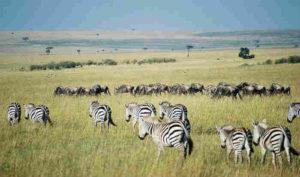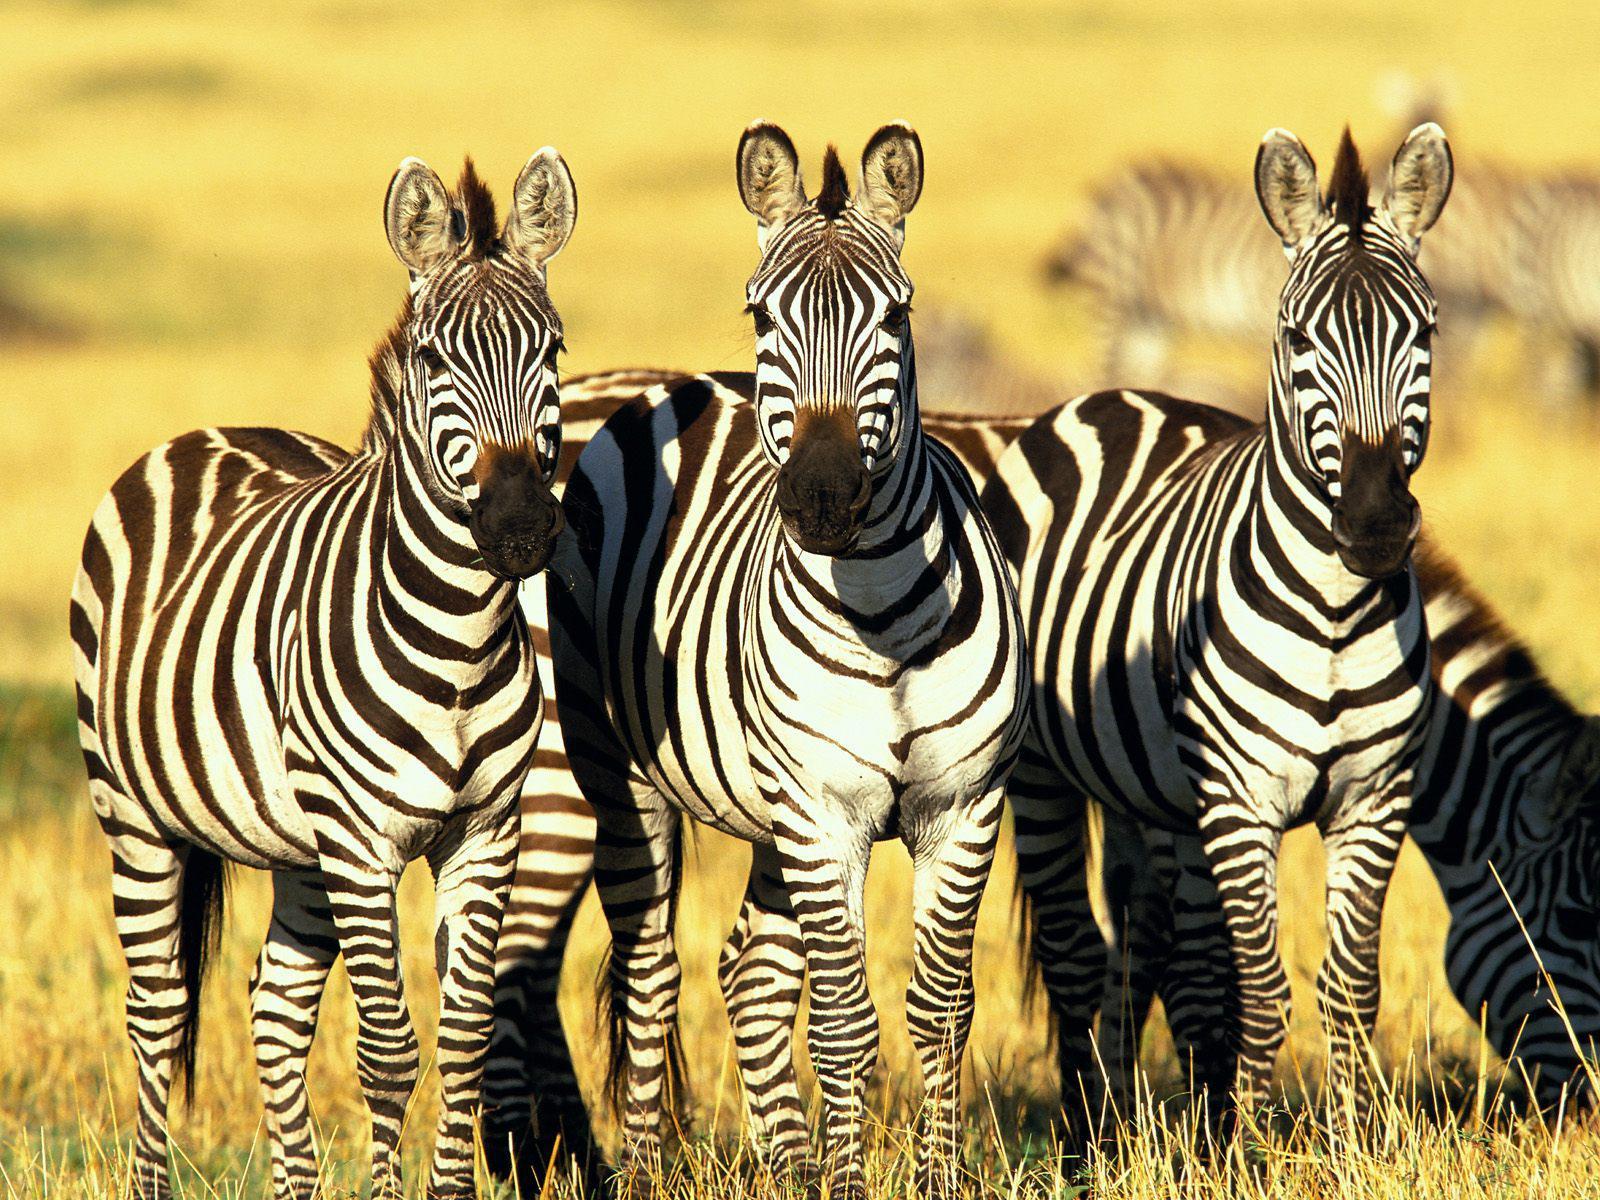The first image is the image on the left, the second image is the image on the right. Assess this claim about the two images: "One image has a trio of zebras standing with bodies turned forward and gazing straight at the camera, in the foreground.". Correct or not? Answer yes or no. Yes. The first image is the image on the left, the second image is the image on the right. For the images displayed, is the sentence "There are three zebras standing side by side in a line and looking straight ahead in one of the images." factually correct? Answer yes or no. Yes. 